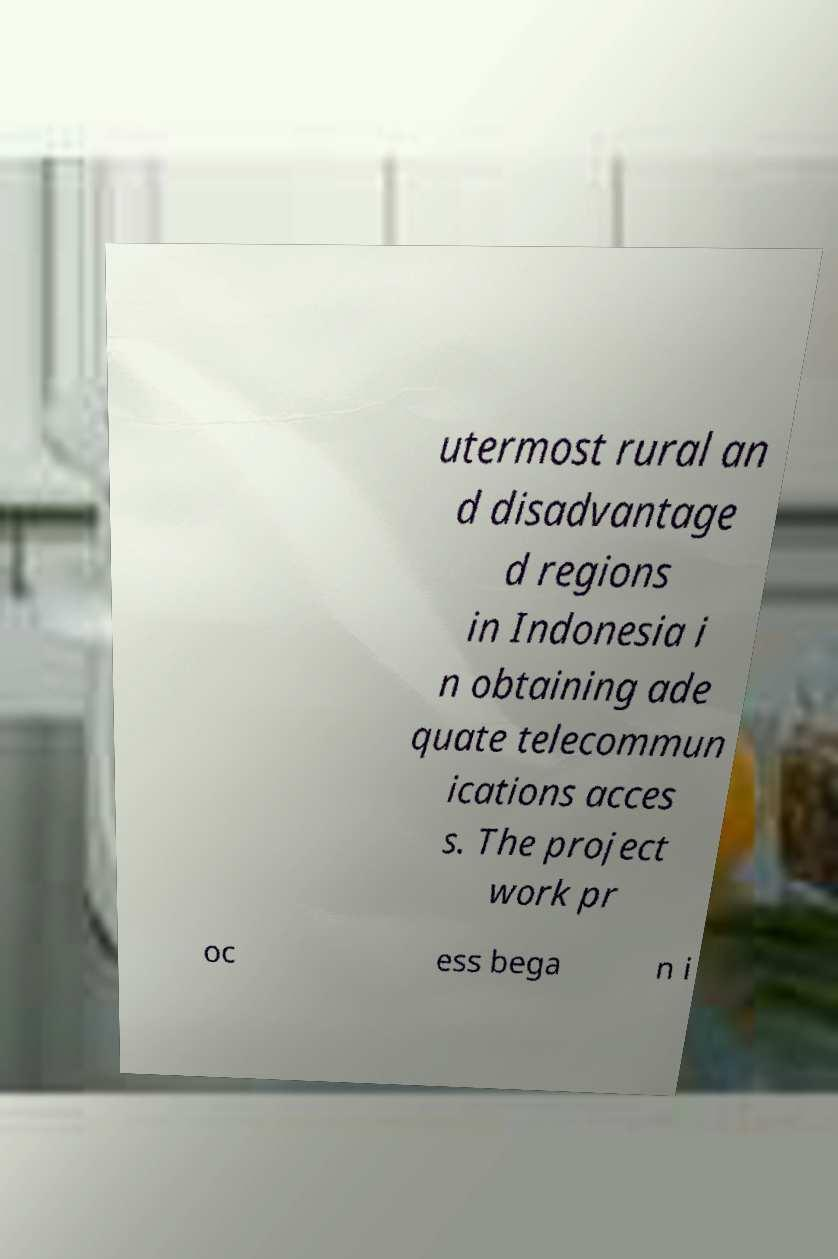Could you assist in decoding the text presented in this image and type it out clearly? utermost rural an d disadvantage d regions in Indonesia i n obtaining ade quate telecommun ications acces s. The project work pr oc ess bega n i 